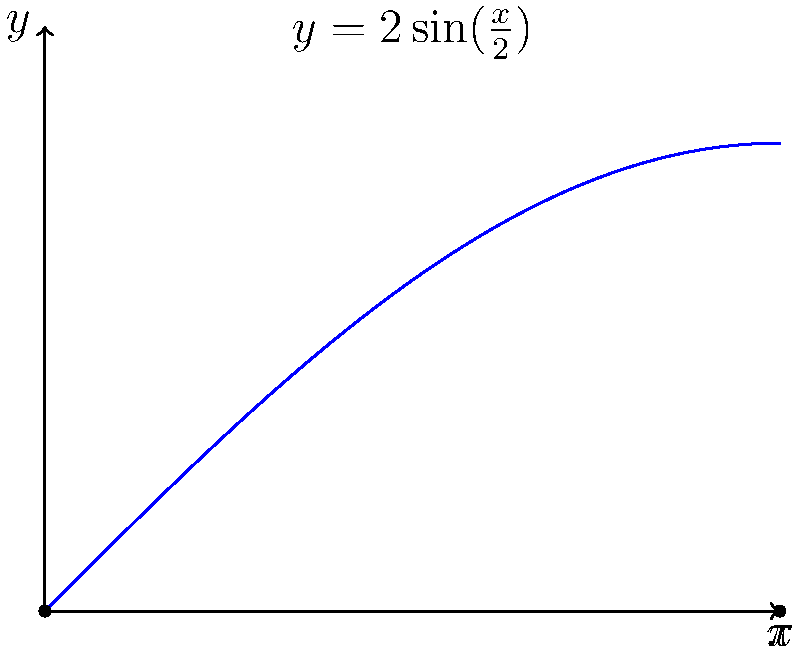In your place of worship, there is a decorative arch that follows the curve $y = 2\sin(\frac{x}{2})$ from $x = 0$ to $x = \pi$. As part of a renovation project, you need to calculate the exact length of this arch. Using trigonometric integration, determine the length of the arch. To find the length of the curved arch, we need to use the arc length formula:

$$L = \int_a^b \sqrt{1 + \left(\frac{dy}{dx}\right)^2} dx$$

Step 1: Find $\frac{dy}{dx}$
$$y = 2\sin(\frac{x}{2})$$
$$\frac{dy}{dx} = 2 \cdot \frac{1}{2} \cos(\frac{x}{2}) = \cos(\frac{x}{2})$$

Step 2: Substitute into the arc length formula
$$L = \int_0^\pi \sqrt{1 + \cos^2(\frac{x}{2})} dx$$

Step 3: Use the trigonometric identity $\cos^2(\theta) = 1 - \sin^2(\theta)$
$$L = \int_0^\pi \sqrt{1 + (1 - \sin^2(\frac{x}{2}))} dx$$
$$L = \int_0^\pi \sqrt{2 - \sin^2(\frac{x}{2})} dx$$

Step 4: Substitute $u = \frac{x}{2}$, so $du = \frac{1}{2}dx$ and when $x = 0$, $u = 0$; when $x = \pi$, $u = \frac{\pi}{2}$
$$L = 2\int_0^{\frac{\pi}{2}} \sqrt{2 - \sin^2(u)} du$$

Step 5: This is a standard elliptic integral. The result is:
$$L = 2 \cdot 2E(\frac{\pi}{2}, \frac{1}{\sqrt{2}})$$

Where $E$ is the elliptic integral of the second kind.

Step 6: Evaluate using a calculator or mathematical software
$$L \approx 7.6404$$
Answer: $7.6404$ units 